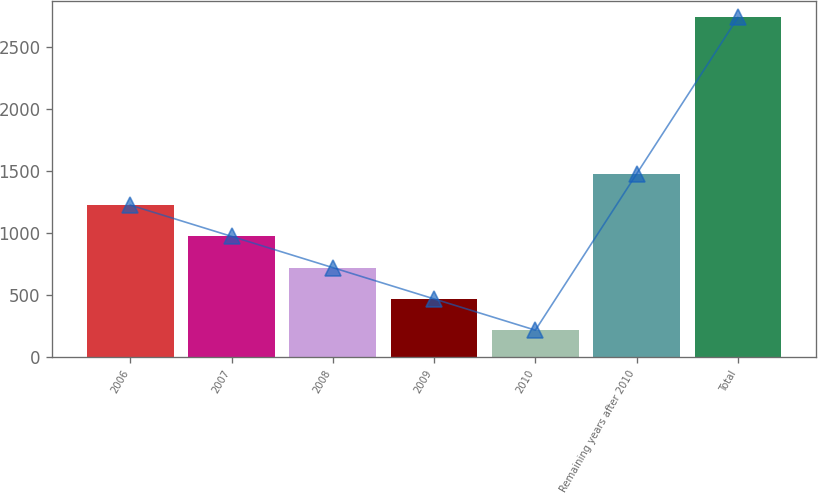<chart> <loc_0><loc_0><loc_500><loc_500><bar_chart><fcel>2006<fcel>2007<fcel>2008<fcel>2009<fcel>2010<fcel>Remaining years after 2010<fcel>Total<nl><fcel>1222.6<fcel>970.7<fcel>718.8<fcel>466.9<fcel>215<fcel>1474.5<fcel>2734<nl></chart> 